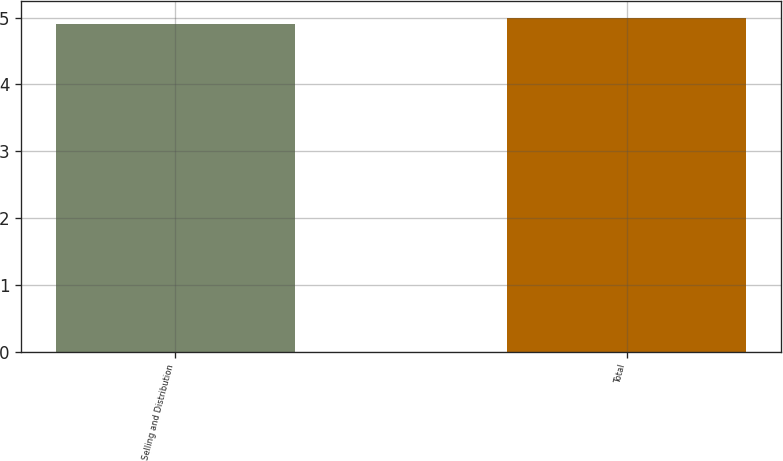<chart> <loc_0><loc_0><loc_500><loc_500><bar_chart><fcel>Selling and Distribution<fcel>Total<nl><fcel>4.9<fcel>5<nl></chart> 